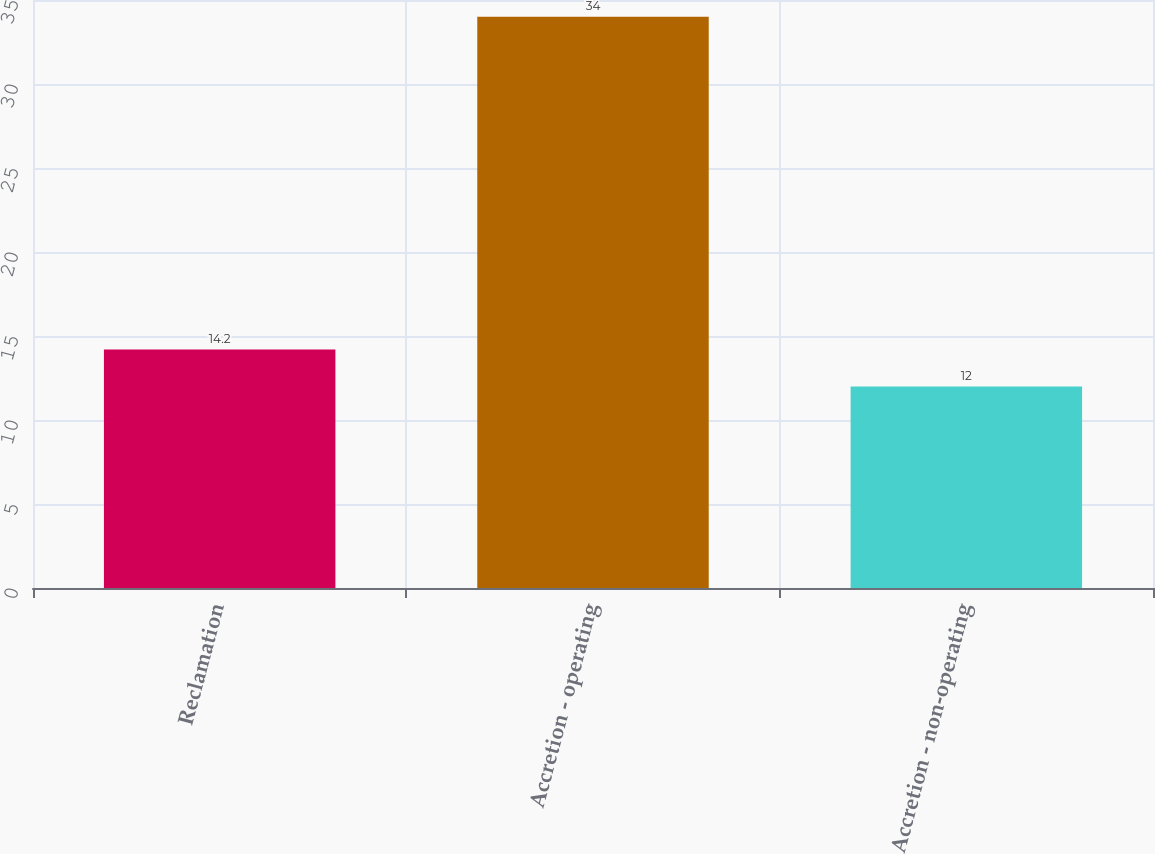Convert chart. <chart><loc_0><loc_0><loc_500><loc_500><bar_chart><fcel>Reclamation<fcel>Accretion - operating<fcel>Accretion - non-operating<nl><fcel>14.2<fcel>34<fcel>12<nl></chart> 